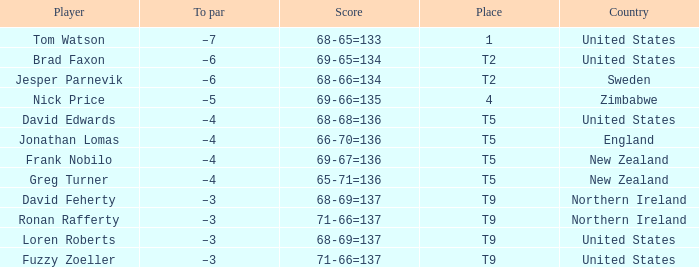The golfer in place 1 if from what country? United States. 